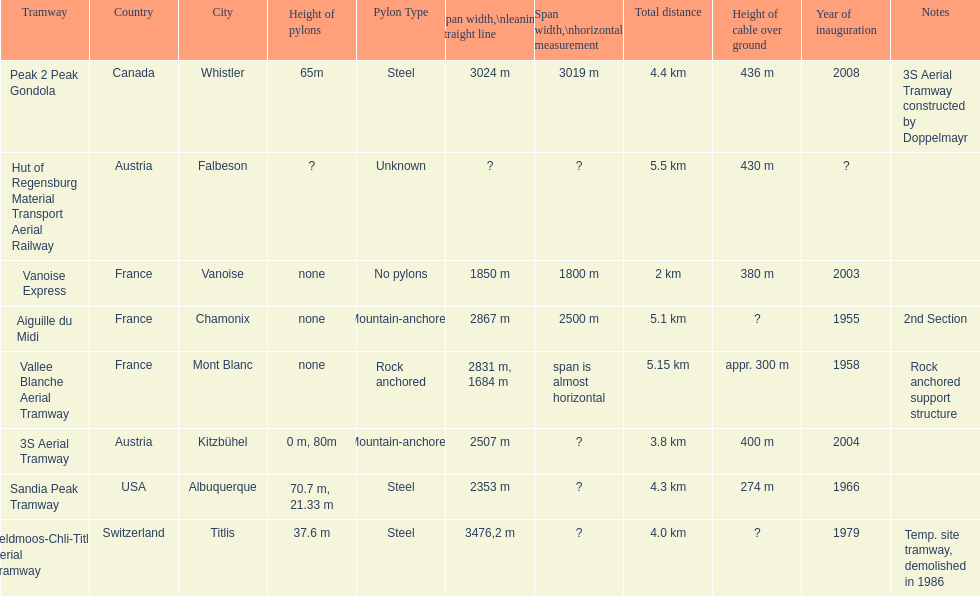Was the peak 2 peak gondola inaugurated before the vanoise express? No. 